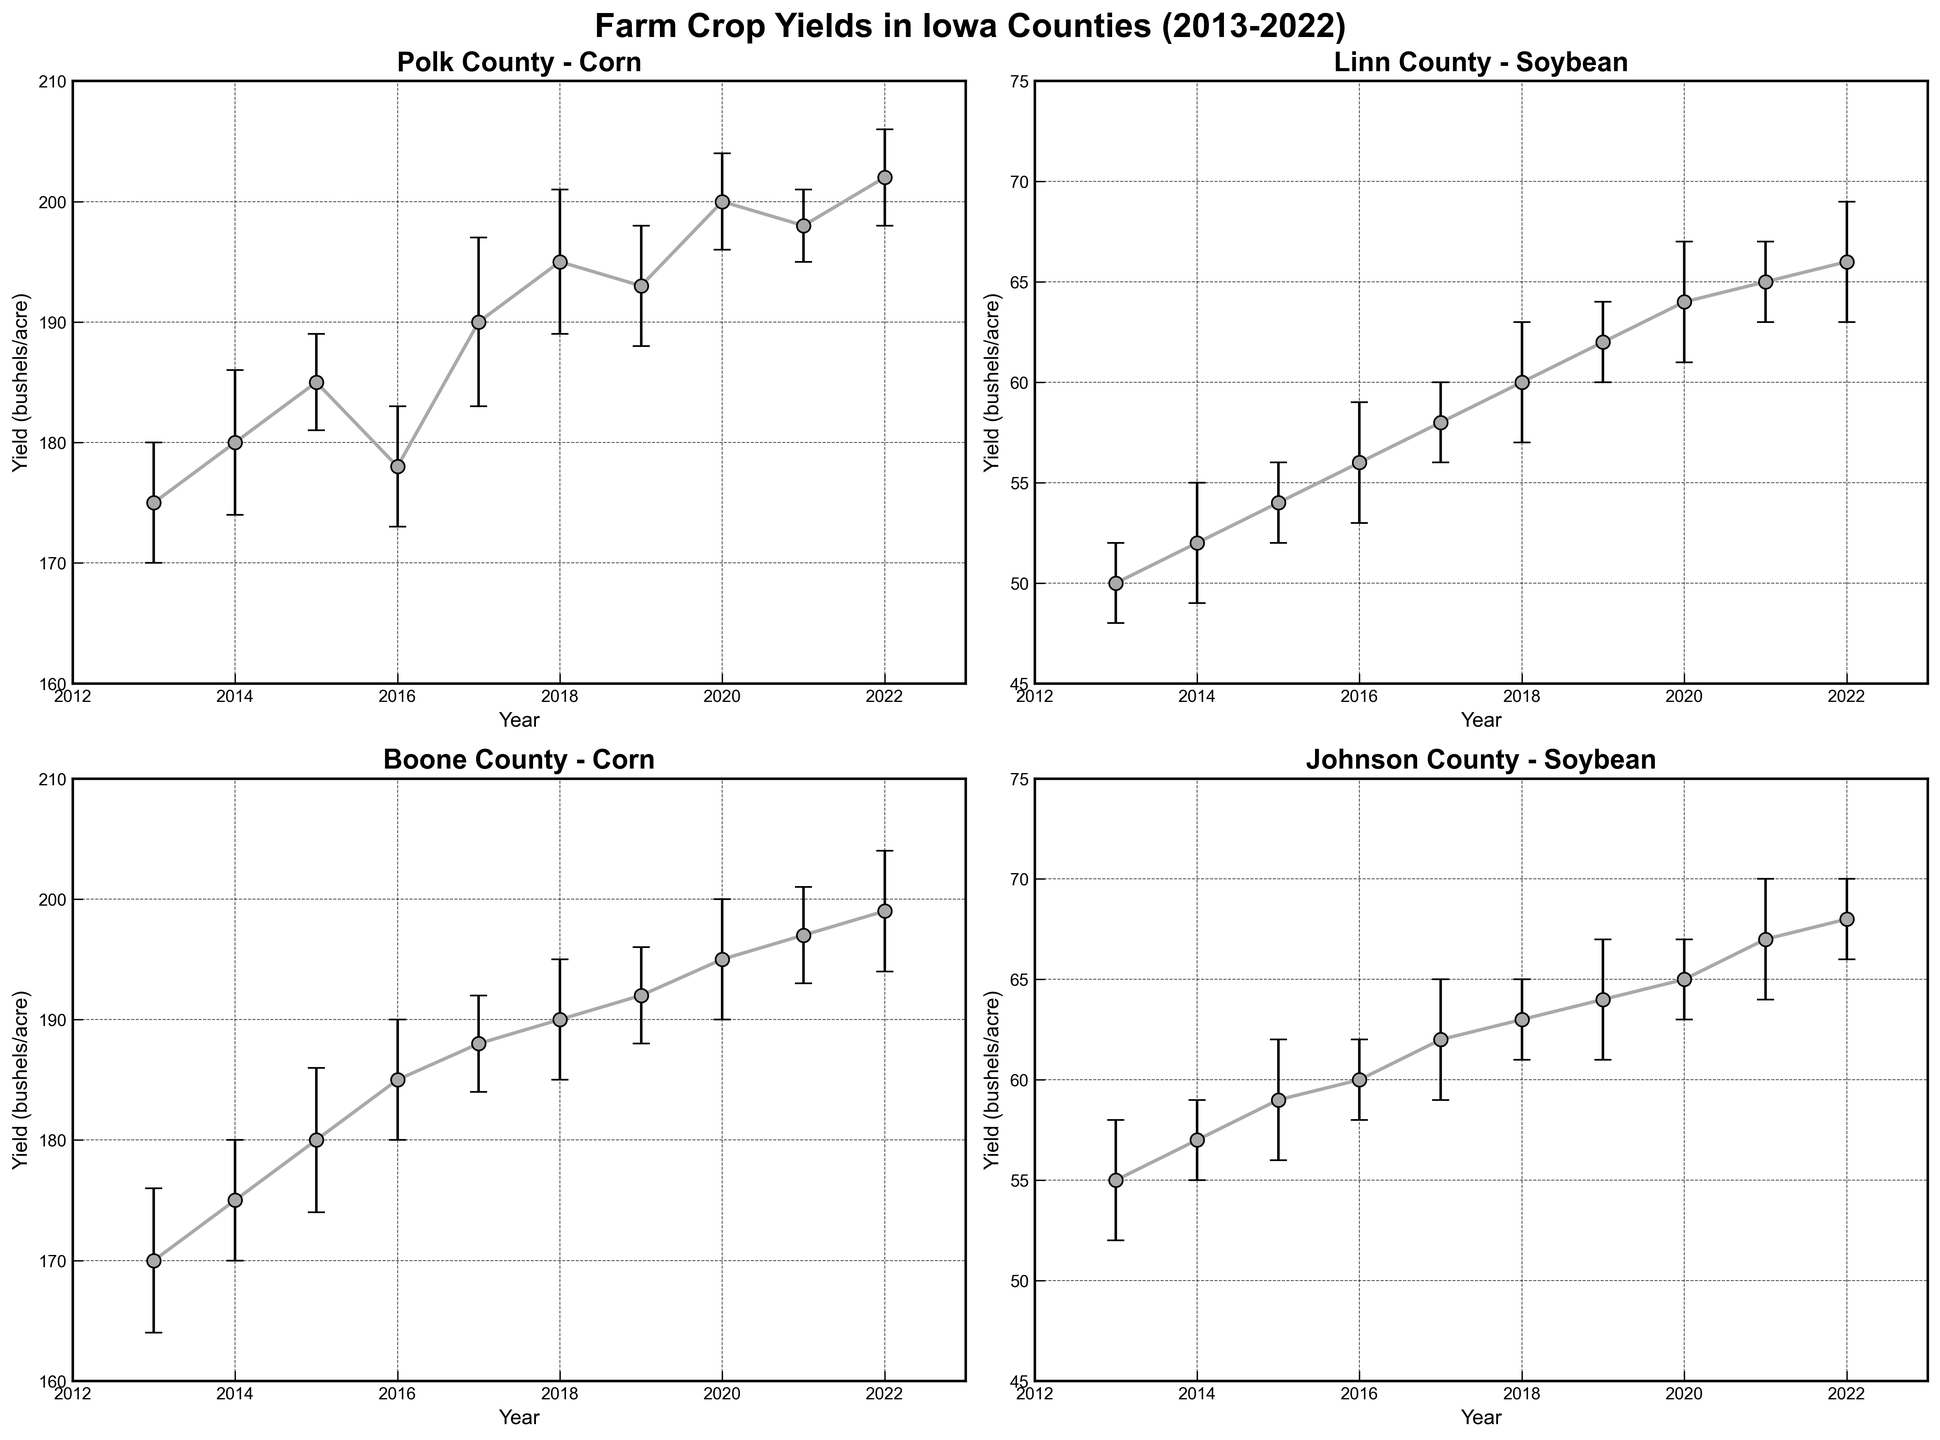Which county shows the highest yield for Corn in 2022? Look for the highest Corn yield value in the subplots for Polk and Boone counties in 2022. Polk shows 202 bushels/acre, and Boone shows 199 bushels/acre.
Answer: Polk What is the average Soybean yield in Linn County from 2013 to 2022? Calculate the sum of the Soybean yields in Linn County for the years provided, then divide by the number of years (10). Sum = 50+52+54+56+58+60+62+64+65+66 = 587. Average = 587/10 = 58.7
Answer: 58.7 How does the yield change trend in Polk County for Corn compare to Boone County for Corn from 2013 to 2022? Both counties show an increasing trend in Corn yield from 2013 to 2022, but Polk has slightly higher yields throughout, and the increases are somewhat more substantial in Polk.
Answer: Increasing, Polk higher Which year shows the maximum yield for Soybean in Johnson County? Look for the highest Soybean yield value in Johnson County's subplot. The highest yield is 68 bushels/acre in 2022.
Answer: 2022 Is there any year where the Corn yield in Polk County has decreased compared to the previous year? Check the plot for Polk County Corn yields for years with a dip compared to the previous year. In 2016, the yield decreased from 185 to 178 bushels/acre.
Answer: 2016 Compare the yield stability for Soybean between Linn and Johnson Counties from 2013 to 2022. Analyze the error margins in both subplots. Linn County has slightly higher error margins, indicating less stability compared to Johnson County.
Answer: Johnson more stable What is the difference in Corn yield between Boone and Polk Counties in 2021? Subtract the 2021 Corn yield value of Boone County from that of Polk County. Boone = 197 and Polk = 198. Difference = 198 - 197 = 1
Answer: 1 If we consider the error margins, what is the possible range for Soybean yield in Linn County in 2019? Add and subtract the error margin from the yield of 62 bushels/acre. Range = 62 ± 2 = 60 to 64 bushels/acre.
Answer: 60 to 64 Which subplot has more consistent yields over the years, Corn in Boone County or Soybean in Johnson County? Compare the year-to-year yield values and error margins of both subplots. Johnson County Soybean shows more consistent yields and lower error margins.
Answer: Soybean in Johnson 